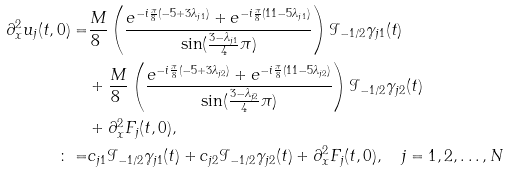Convert formula to latex. <formula><loc_0><loc_0><loc_500><loc_500>\partial _ { x } ^ { 2 } u _ { j } ( t , 0 ) = & \frac { M } { 8 \ } \left ( \frac { e ^ { - i \frac { \pi } { 8 } ( - 5 + 3 \lambda _ { j 1 } ) } + e ^ { - i \frac { \pi } { 8 } ( 1 1 - 5 \lambda _ { j 1 } ) } } { \sin ( \frac { 3 - \lambda _ { j 1 } } { 4 } \pi ) } \right ) \mathcal { I } _ { - 1 / 2 } \gamma _ { j 1 } ( t ) \\ & + \frac { M } { 8 \ } \left ( \frac { e ^ { - i \frac { \pi } { 8 } ( - 5 + 3 \lambda _ { j 2 } ) } + e ^ { - i \frac { \pi } { 8 } ( 1 1 - 5 \lambda _ { j 2 } ) } } { \sin ( \frac { 3 - \lambda _ { j 2 } } { 4 } \pi ) } \right ) \mathcal { I } _ { - 1 / 2 } \gamma _ { j 2 } ( t ) \\ & + \partial _ { x } ^ { 2 } F _ { j } ( t , 0 ) , \\ \colon = & c _ { j 1 } \mathcal { I } _ { - 1 / 2 } \gamma _ { j 1 } ( t ) + c _ { j 2 } \mathcal { I } _ { - 1 / 2 } \gamma _ { j 2 } ( t ) + \partial _ { x } ^ { 2 } F _ { j } ( t , 0 ) , \quad j = 1 , 2 , \dots , N</formula> 